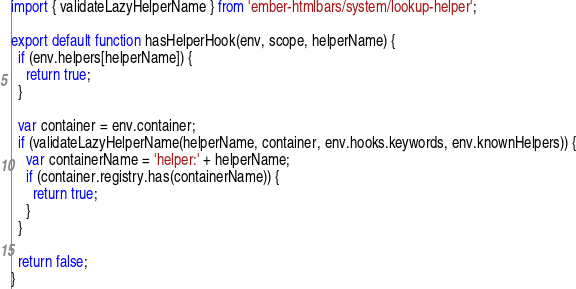<code> <loc_0><loc_0><loc_500><loc_500><_JavaScript_>import { validateLazyHelperName } from 'ember-htmlbars/system/lookup-helper';

export default function hasHelperHook(env, scope, helperName) {
  if (env.helpers[helperName]) {
    return true;
  }

  var container = env.container;
  if (validateLazyHelperName(helperName, container, env.hooks.keywords, env.knownHelpers)) {
    var containerName = 'helper:' + helperName;
    if (container.registry.has(containerName)) {
      return true;
    }
  }

  return false;
}
</code> 